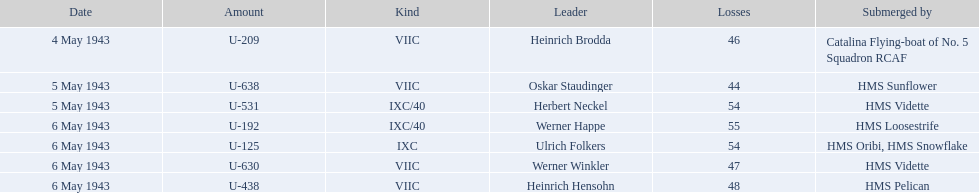What boats were lost on may 5? U-638, U-531. Who were the captains of those boats? Oskar Staudinger, Herbert Neckel. Which captain was not oskar staudinger? Herbert Neckel. 